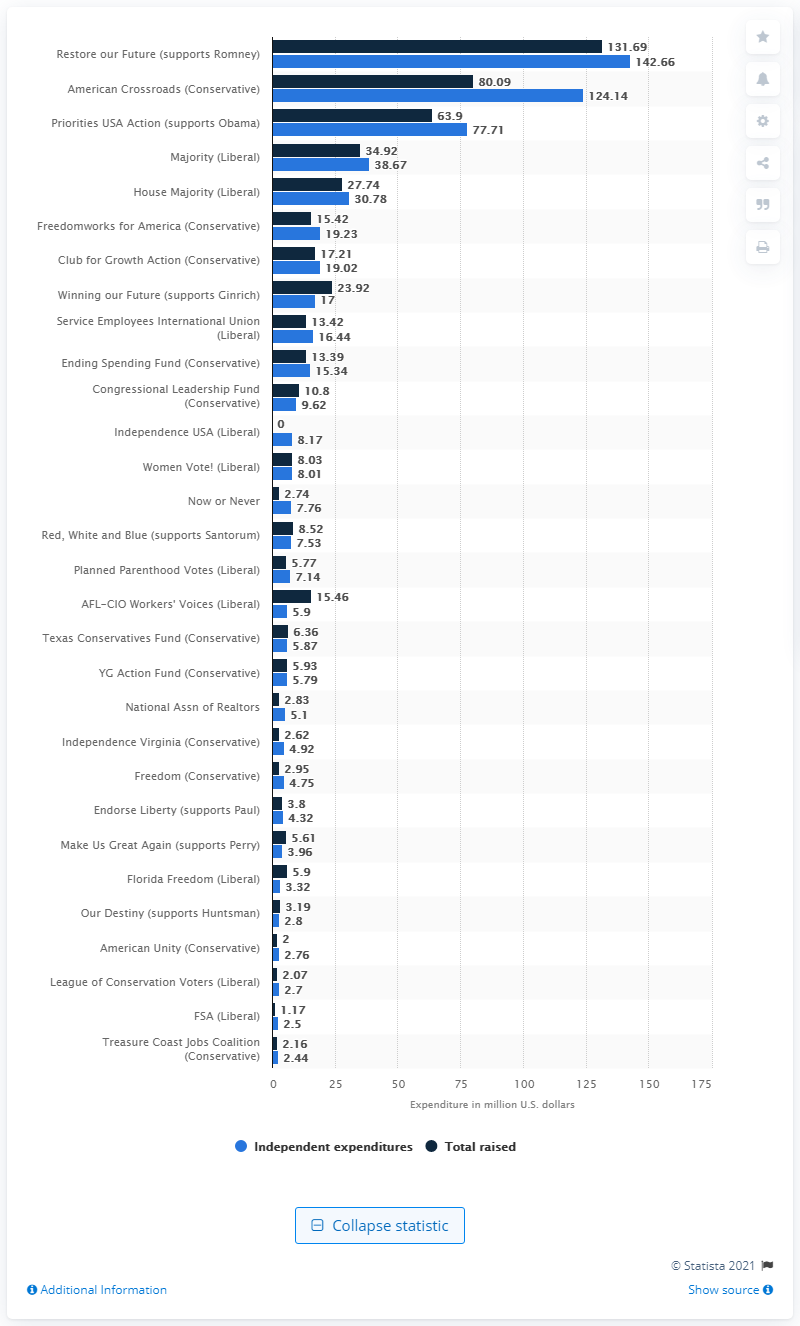Mention a couple of crucial points in this snapshot. According to records, "Restore Our Future" spent 142.66 on supporting Mitt Romney. 